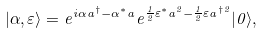Convert formula to latex. <formula><loc_0><loc_0><loc_500><loc_500>| \alpha , \varepsilon \rangle = e ^ { i \alpha a ^ { \dagger } - \alpha ^ { \ast } a } e ^ { \frac { 1 } { 2 } \varepsilon ^ { \ast } a ^ { 2 } - \frac { 1 } { 2 } \varepsilon a ^ { \dagger 2 } } | 0 \rangle ,</formula> 